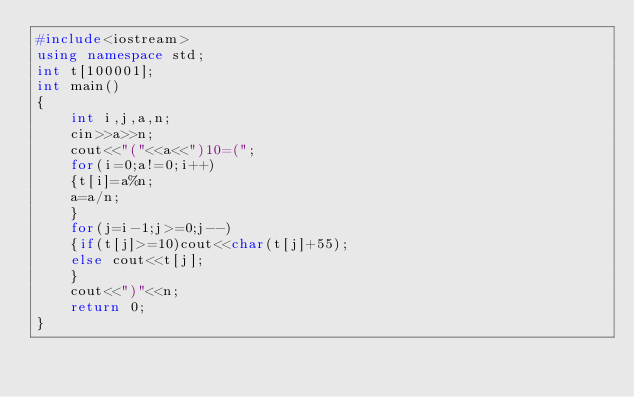Convert code to text. <code><loc_0><loc_0><loc_500><loc_500><_C++_>#include<iostream>
using namespace std;
int t[100001];
int main()
{
	int i,j,a,n;
	cin>>a>>n;
	cout<<"("<<a<<")10=(";
	for(i=0;a!=0;i++)
	{t[i]=a%n;
	a=a/n;
	}
	for(j=i-1;j>=0;j--)
	{if(t[j]>=10)cout<<char(t[j]+55);
	else cout<<t[j];
	}
	cout<<")"<<n;
	return 0;
}</code> 